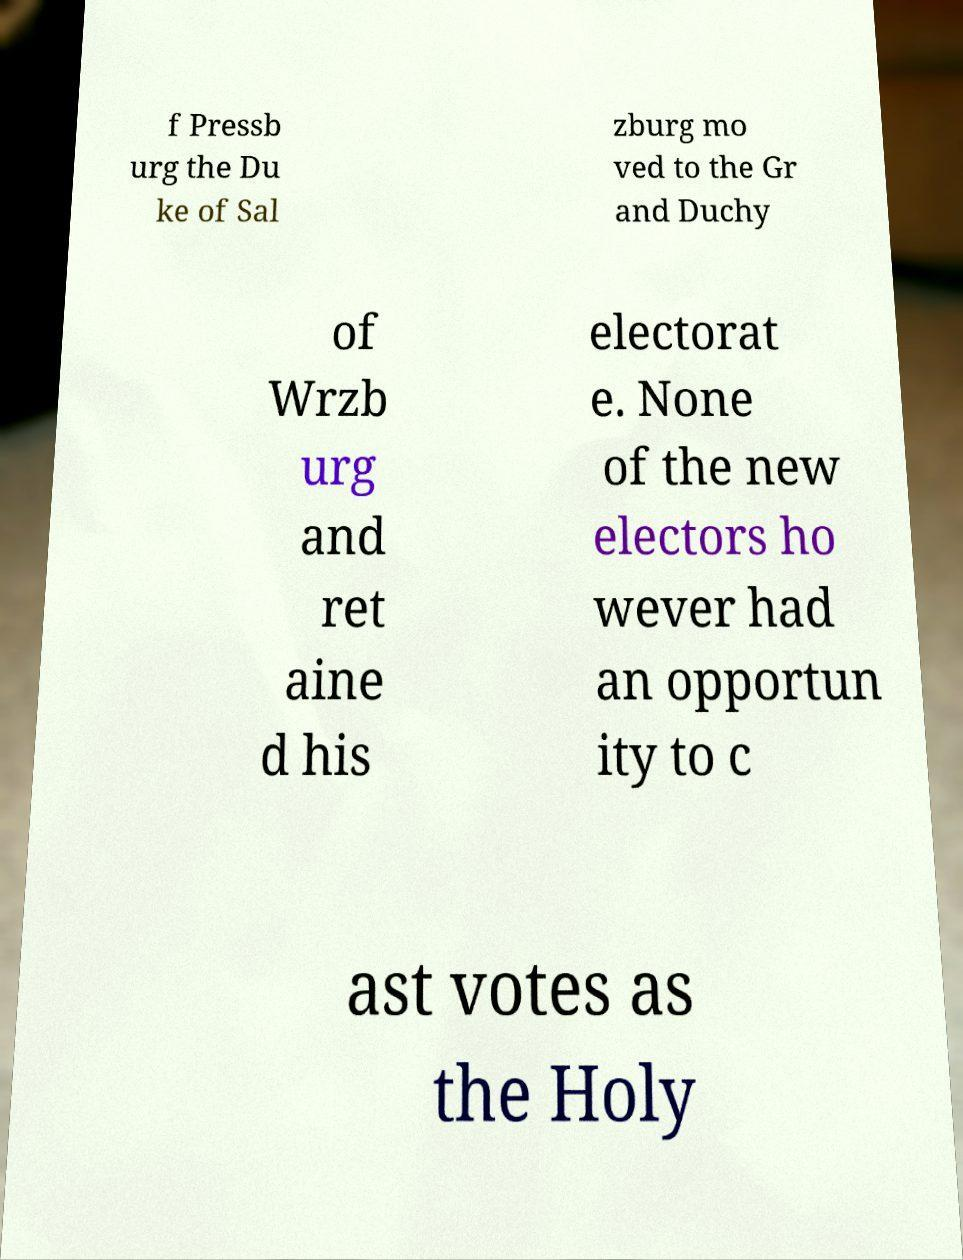Please identify and transcribe the text found in this image. f Pressb urg the Du ke of Sal zburg mo ved to the Gr and Duchy of Wrzb urg and ret aine d his electorat e. None of the new electors ho wever had an opportun ity to c ast votes as the Holy 